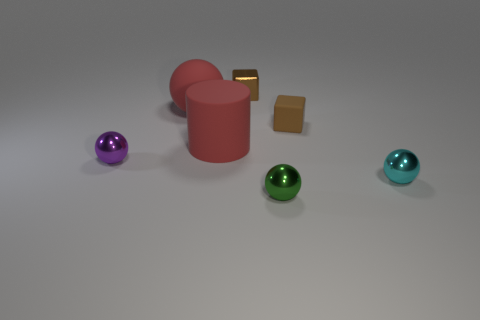The metal object that is the same color as the small matte block is what size?
Provide a short and direct response. Small. Are the small brown thing that is in front of the small brown shiny thing and the thing that is in front of the cyan shiny object made of the same material?
Provide a short and direct response. No. How many objects are objects that are in front of the cyan object or small metal balls that are behind the small cyan shiny thing?
Your answer should be compact. 2. There is a red rubber thing on the right side of the ball that is behind the small purple shiny ball; what size is it?
Your answer should be very brief. Large. The green ball is what size?
Offer a terse response. Small. Does the block that is on the right side of the tiny green shiny thing have the same color as the tiny metallic object behind the red rubber cylinder?
Your response must be concise. Yes. How many other objects are there of the same material as the purple object?
Make the answer very short. 3. Are there any tiny purple things?
Your answer should be compact. Yes. Does the sphere that is behind the purple sphere have the same material as the green ball?
Keep it short and to the point. No. There is a red thing that is the same shape as the green metallic object; what is it made of?
Give a very brief answer. Rubber. 